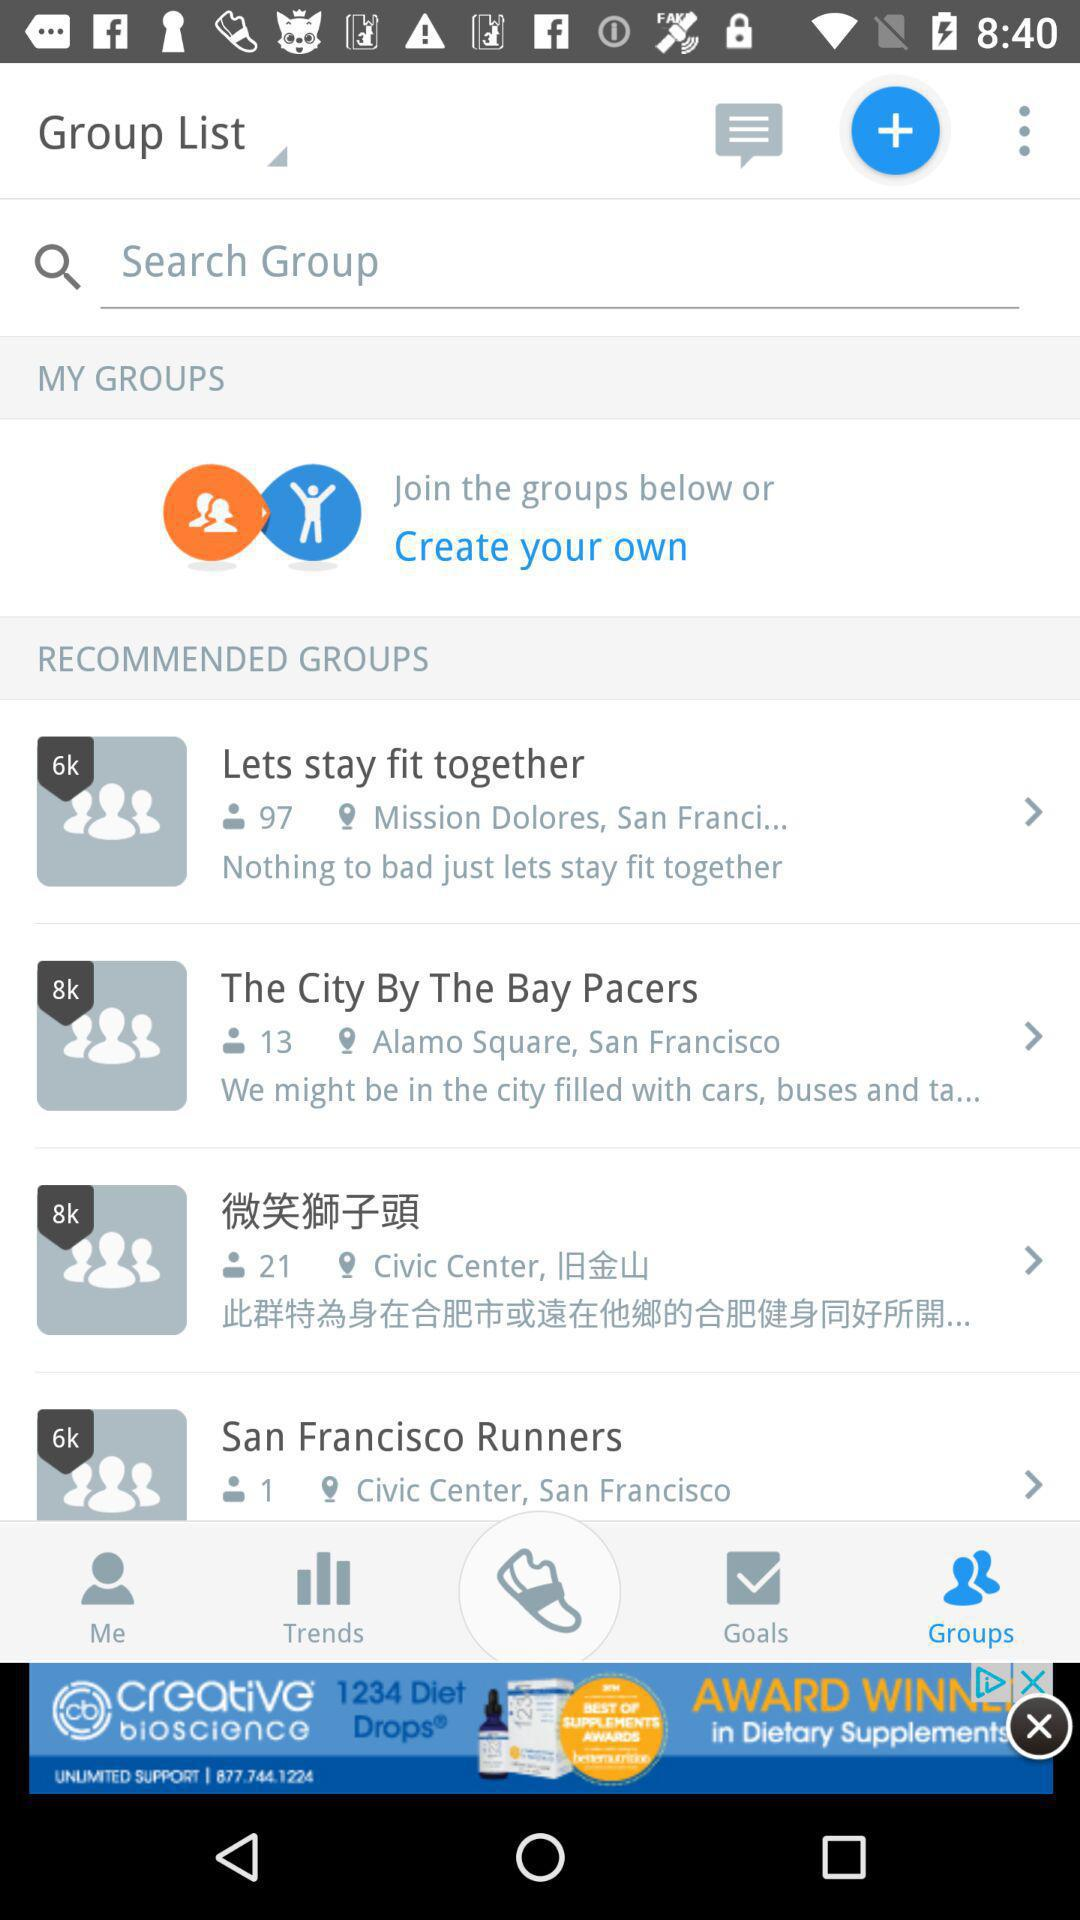Which group has been joined by 13 people? The group that has been joined by 13 people is "The City By The Bay Pacers". 